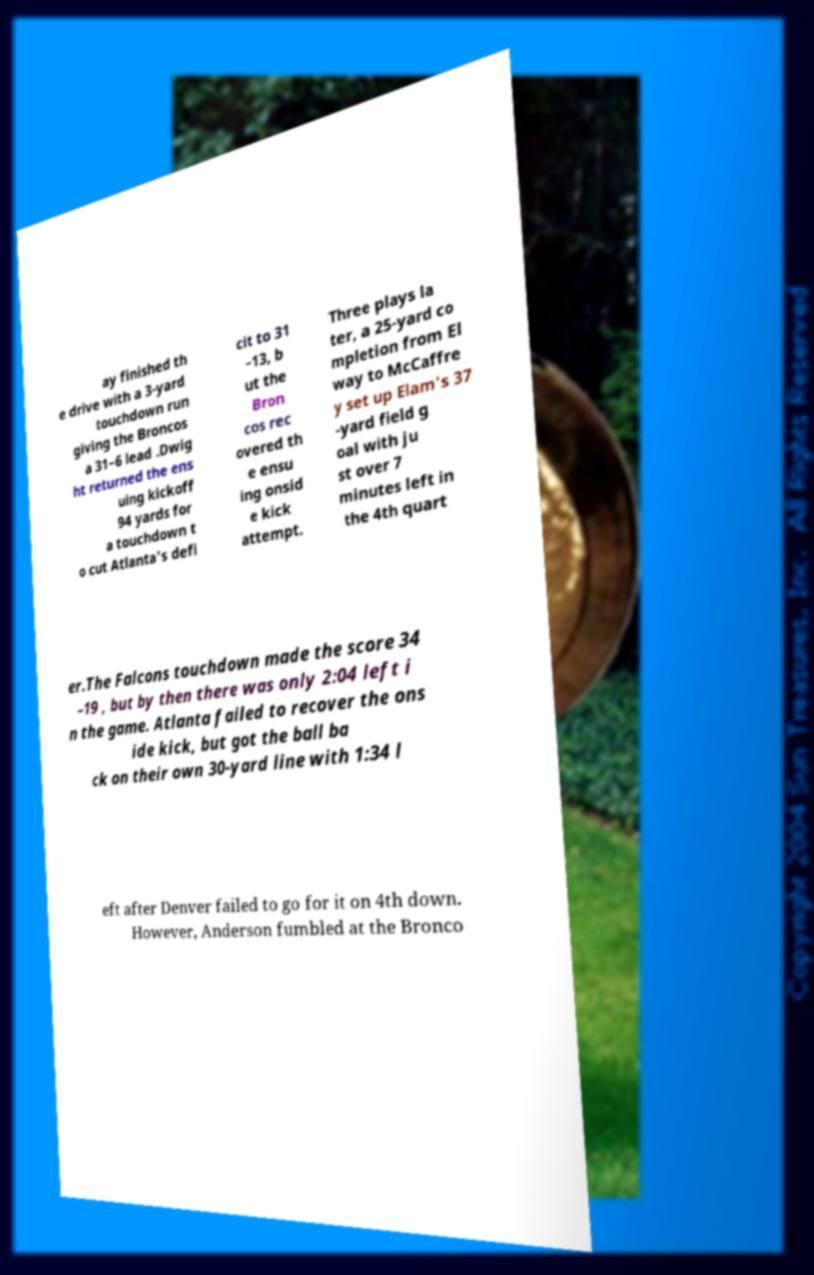Please read and relay the text visible in this image. What does it say? ay finished th e drive with a 3-yard touchdown run giving the Broncos a 31–6 lead .Dwig ht returned the ens uing kickoff 94 yards for a touchdown t o cut Atlanta's defi cit to 31 –13, b ut the Bron cos rec overed th e ensu ing onsid e kick attempt. Three plays la ter, a 25-yard co mpletion from El way to McCaffre y set up Elam's 37 -yard field g oal with ju st over 7 minutes left in the 4th quart er.The Falcons touchdown made the score 34 –19 , but by then there was only 2:04 left i n the game. Atlanta failed to recover the ons ide kick, but got the ball ba ck on their own 30-yard line with 1:34 l eft after Denver failed to go for it on 4th down. However, Anderson fumbled at the Bronco 